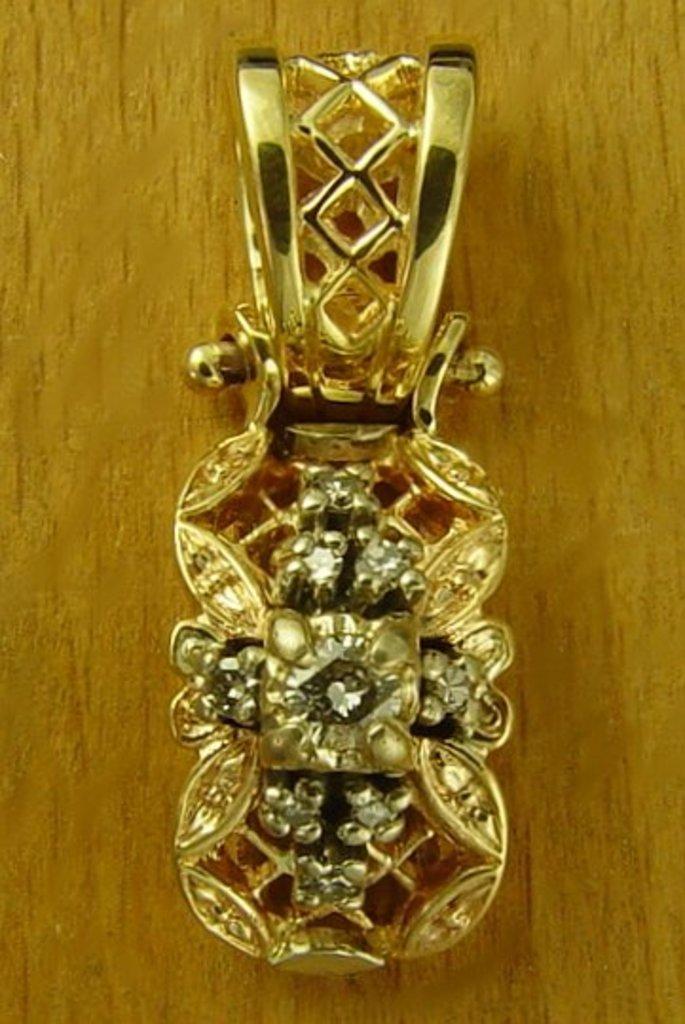Please provide a concise description of this image. In the center of the image, we can see an ornament on the table. 